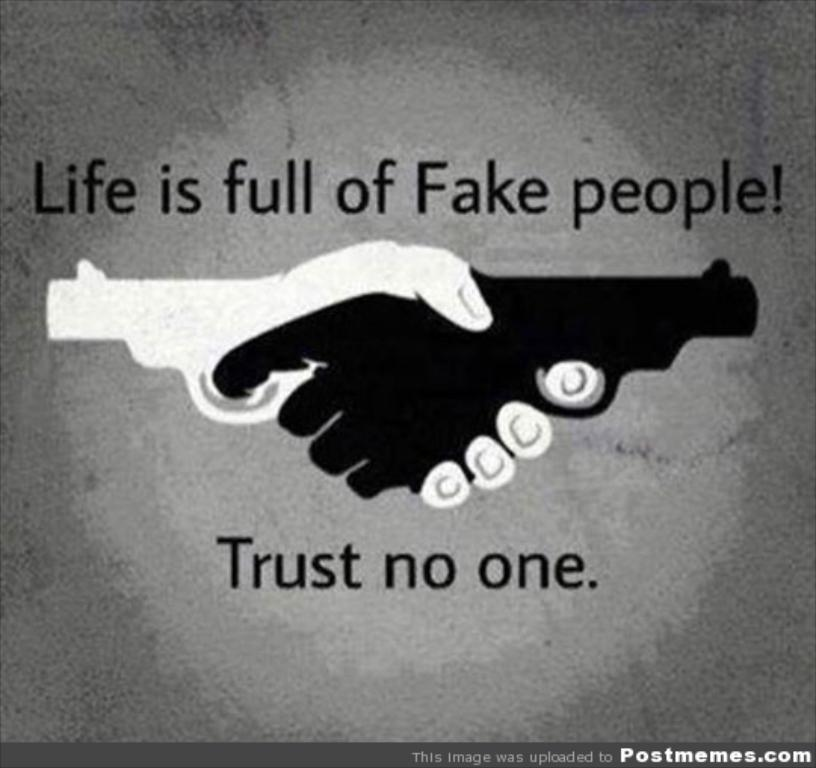Provide a one-sentence caption for the provided image. A poster of two hands shaking that says "Life is fun of Fake people!". 